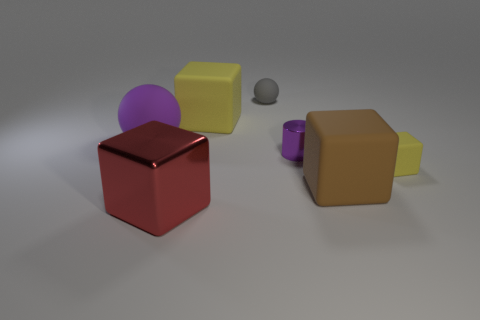Subtract all green cylinders. How many yellow cubes are left? 2 Subtract all big metal blocks. How many blocks are left? 3 Subtract 1 cubes. How many cubes are left? 3 Subtract all red cubes. How many cubes are left? 3 Subtract all red blocks. Subtract all gray cylinders. How many blocks are left? 3 Add 3 blue metal cylinders. How many objects exist? 10 Subtract all blocks. How many objects are left? 3 Add 6 tiny rubber balls. How many tiny rubber balls are left? 7 Add 1 purple rubber things. How many purple rubber things exist? 2 Subtract 0 yellow cylinders. How many objects are left? 7 